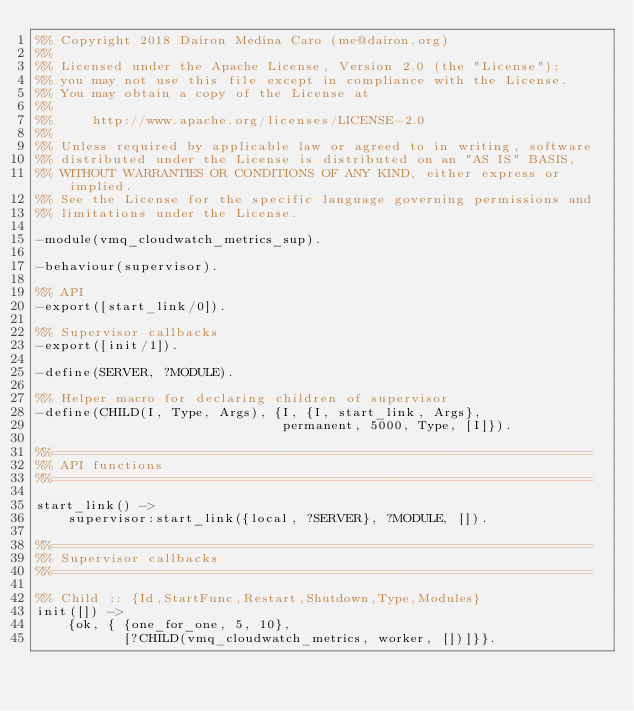Convert code to text. <code><loc_0><loc_0><loc_500><loc_500><_Erlang_>%% Copyright 2018 Dairon Medina Caro (me@dairon.org)
%%
%% Licensed under the Apache License, Version 2.0 (the "License");
%% you may not use this file except in compliance with the License.
%% You may obtain a copy of the License at
%%
%%     http://www.apache.org/licenses/LICENSE-2.0
%%
%% Unless required by applicable law or agreed to in writing, software
%% distributed under the License is distributed on an "AS IS" BASIS,
%% WITHOUT WARRANTIES OR CONDITIONS OF ANY KIND, either express or implied.
%% See the License for the specific language governing permissions and
%% limitations under the License.

-module(vmq_cloudwatch_metrics_sup).

-behaviour(supervisor).

%% API
-export([start_link/0]).

%% Supervisor callbacks
-export([init/1]).

-define(SERVER, ?MODULE).

%% Helper macro for declaring children of supervisor
-define(CHILD(I, Type, Args), {I, {I, start_link, Args},
                               permanent, 5000, Type, [I]}).

%%====================================================================
%% API functions
%%====================================================================

start_link() ->
    supervisor:start_link({local, ?SERVER}, ?MODULE, []).

%%====================================================================
%% Supervisor callbacks
%%====================================================================

%% Child :: {Id,StartFunc,Restart,Shutdown,Type,Modules}
init([]) ->
    {ok, { {one_for_one, 5, 10},
           [?CHILD(vmq_cloudwatch_metrics, worker, [])]}}.
</code> 